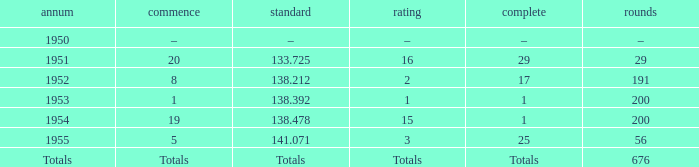What year was the ranking 1? 1953.0. 